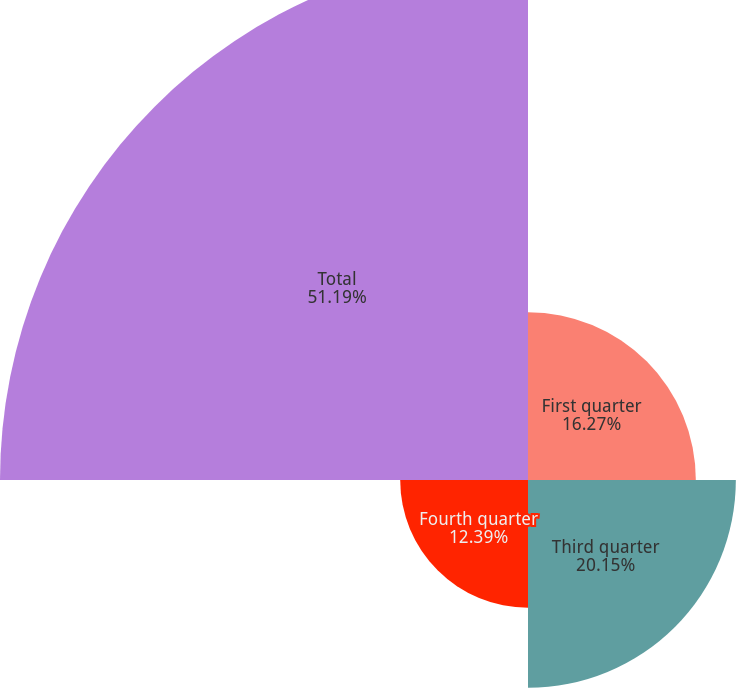<chart> <loc_0><loc_0><loc_500><loc_500><pie_chart><fcel>First quarter<fcel>Third quarter<fcel>Fourth quarter<fcel>Total<nl><fcel>16.27%<fcel>20.15%<fcel>12.39%<fcel>51.19%<nl></chart> 